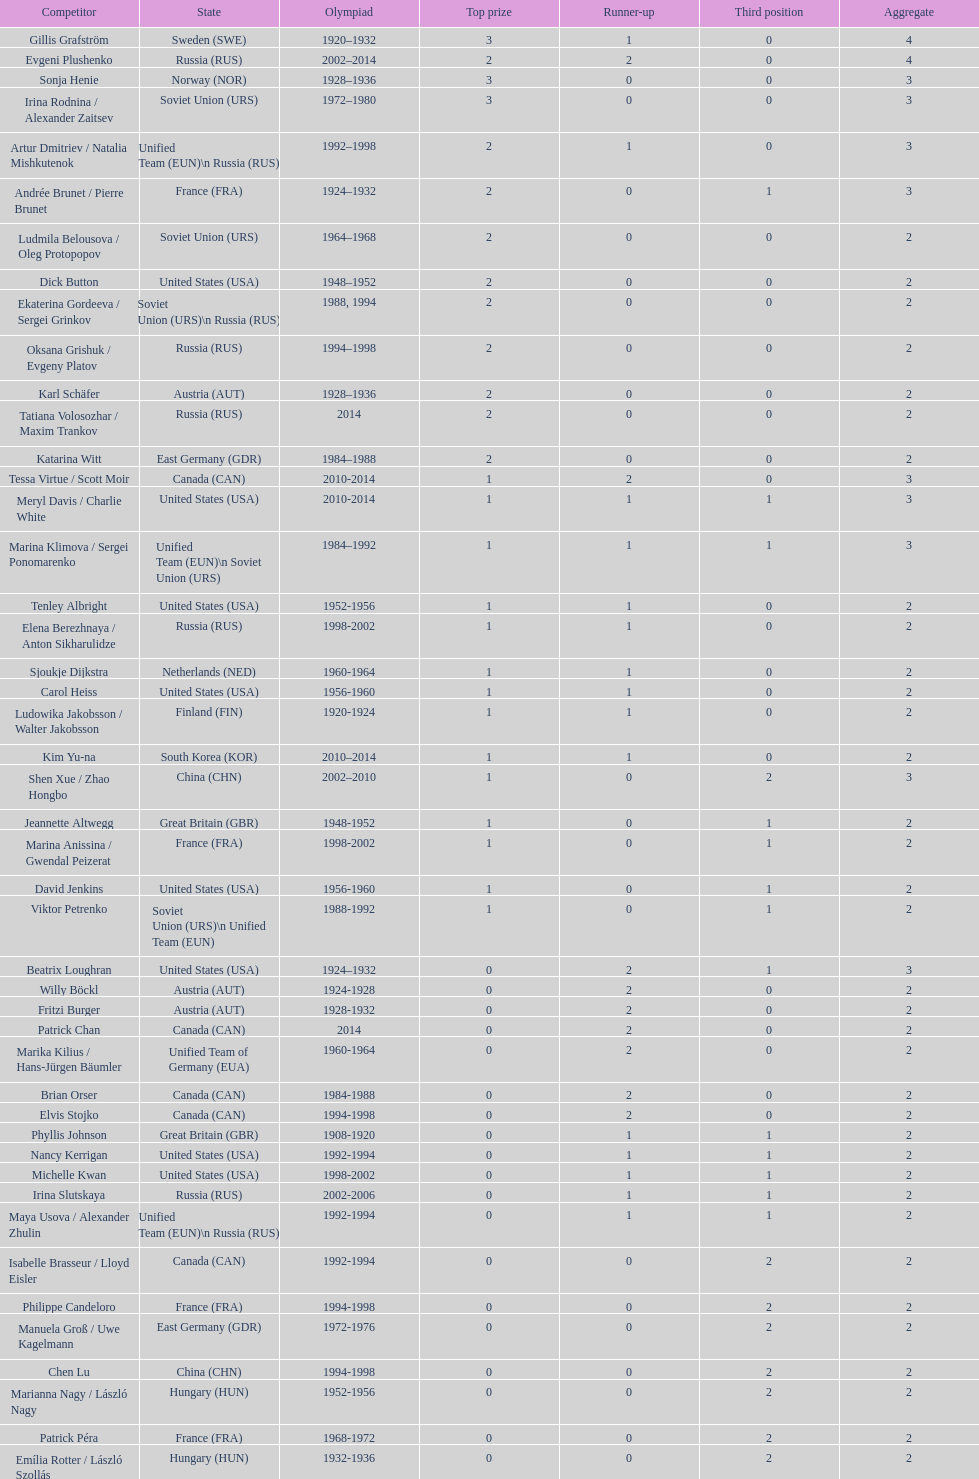How many more silver medals did gillis grafström have compared to sonja henie? 1. 